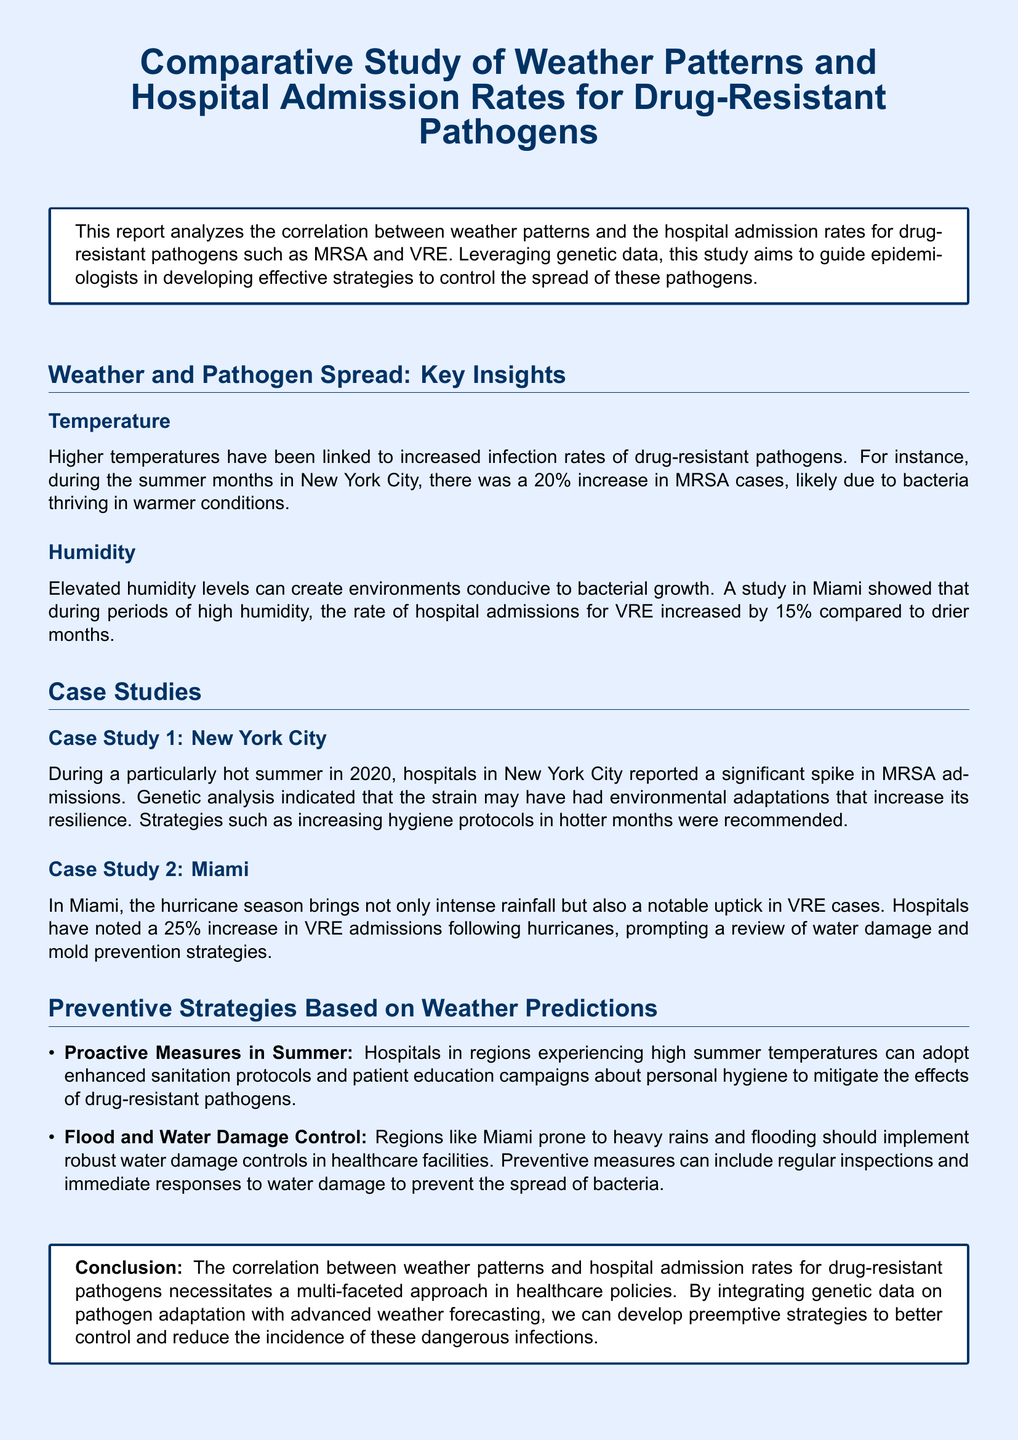What was the percentage increase in MRSA cases during summer in New York City? The document states that there was a 20% increase in MRSA cases during the summer months in New York City.
Answer: 20% What is the primary pathogen studied in Miami? The report mentions that the primary pathogen studied in Miami is VRE, particularly during humid periods.
Answer: VRE What was the increase in VRE admissions following hurricanes in Miami? The document indicates a 25% increase in VRE admissions following hurricanes in Miami.
Answer: 25% What proactive measure is recommended for hospitals in high summer temperatures? The document suggests that hospitals can adopt enhanced sanitation protocols during high summer temperatures.
Answer: Enhanced sanitation protocols What year was particularly hot in New York City according to the report? The case study mentions the hot summer in New York City during the year 2020.
Answer: 2020 Which two factors are highlighted as influencing pathogen spread? The report highlights temperature and humidity as key factors influencing pathogen spread.
Answer: Temperature and humidity What is the conclusion regarding the correlation between weather patterns and hospital admissions? The conclusion states that the correlation necessitates a multi-faceted approach in healthcare policies.
Answer: Multi-faceted approach What control strategy is suggested for regions prone to heavy rains? The document suggests implementing robust water damage controls in healthcare facilities for regions prone to heavy rains.
Answer: Robust water damage controls What environmental condition in Miami leads to a spike in VRE cases? The report indicates that high humidity levels contribute to an increase in VRE cases.
Answer: High humidity levels 